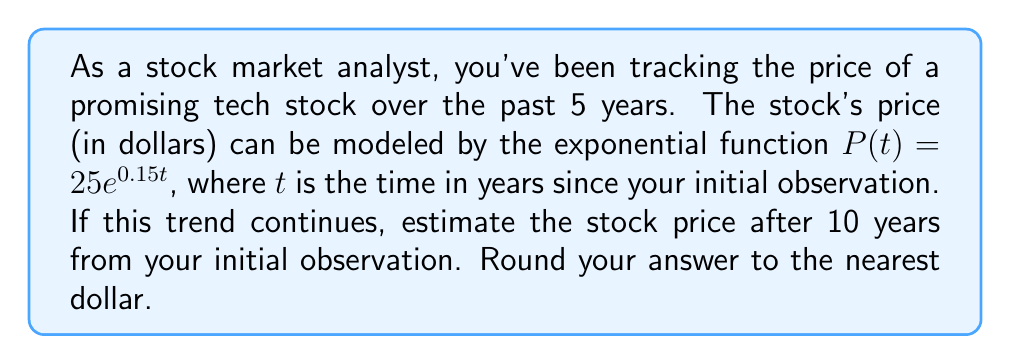Give your solution to this math problem. To solve this problem, we'll follow these steps:

1) We're given the exponential function for the stock price:
   $P(t) = 25e^{0.15t}$

2) We need to find $P(10)$, as we're asked about the price after 10 years:
   $P(10) = 25e^{0.15(10)}$

3) Let's simplify the exponent:
   $P(10) = 25e^{1.5}$

4) Now, we can calculate this value:
   $P(10) = 25 * e^{1.5}$
   $P(10) = 25 * 4.4816890703380645$
   $P(10) = 112.04222675845161$

5) Rounding to the nearest dollar:
   $P(10) ≈ 112$

Therefore, after 10 years, the estimated stock price would be approximately $112.
Answer: $112 